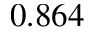Convert formula to latex. <formula><loc_0><loc_0><loc_500><loc_500>0 . 8 6 4</formula> 